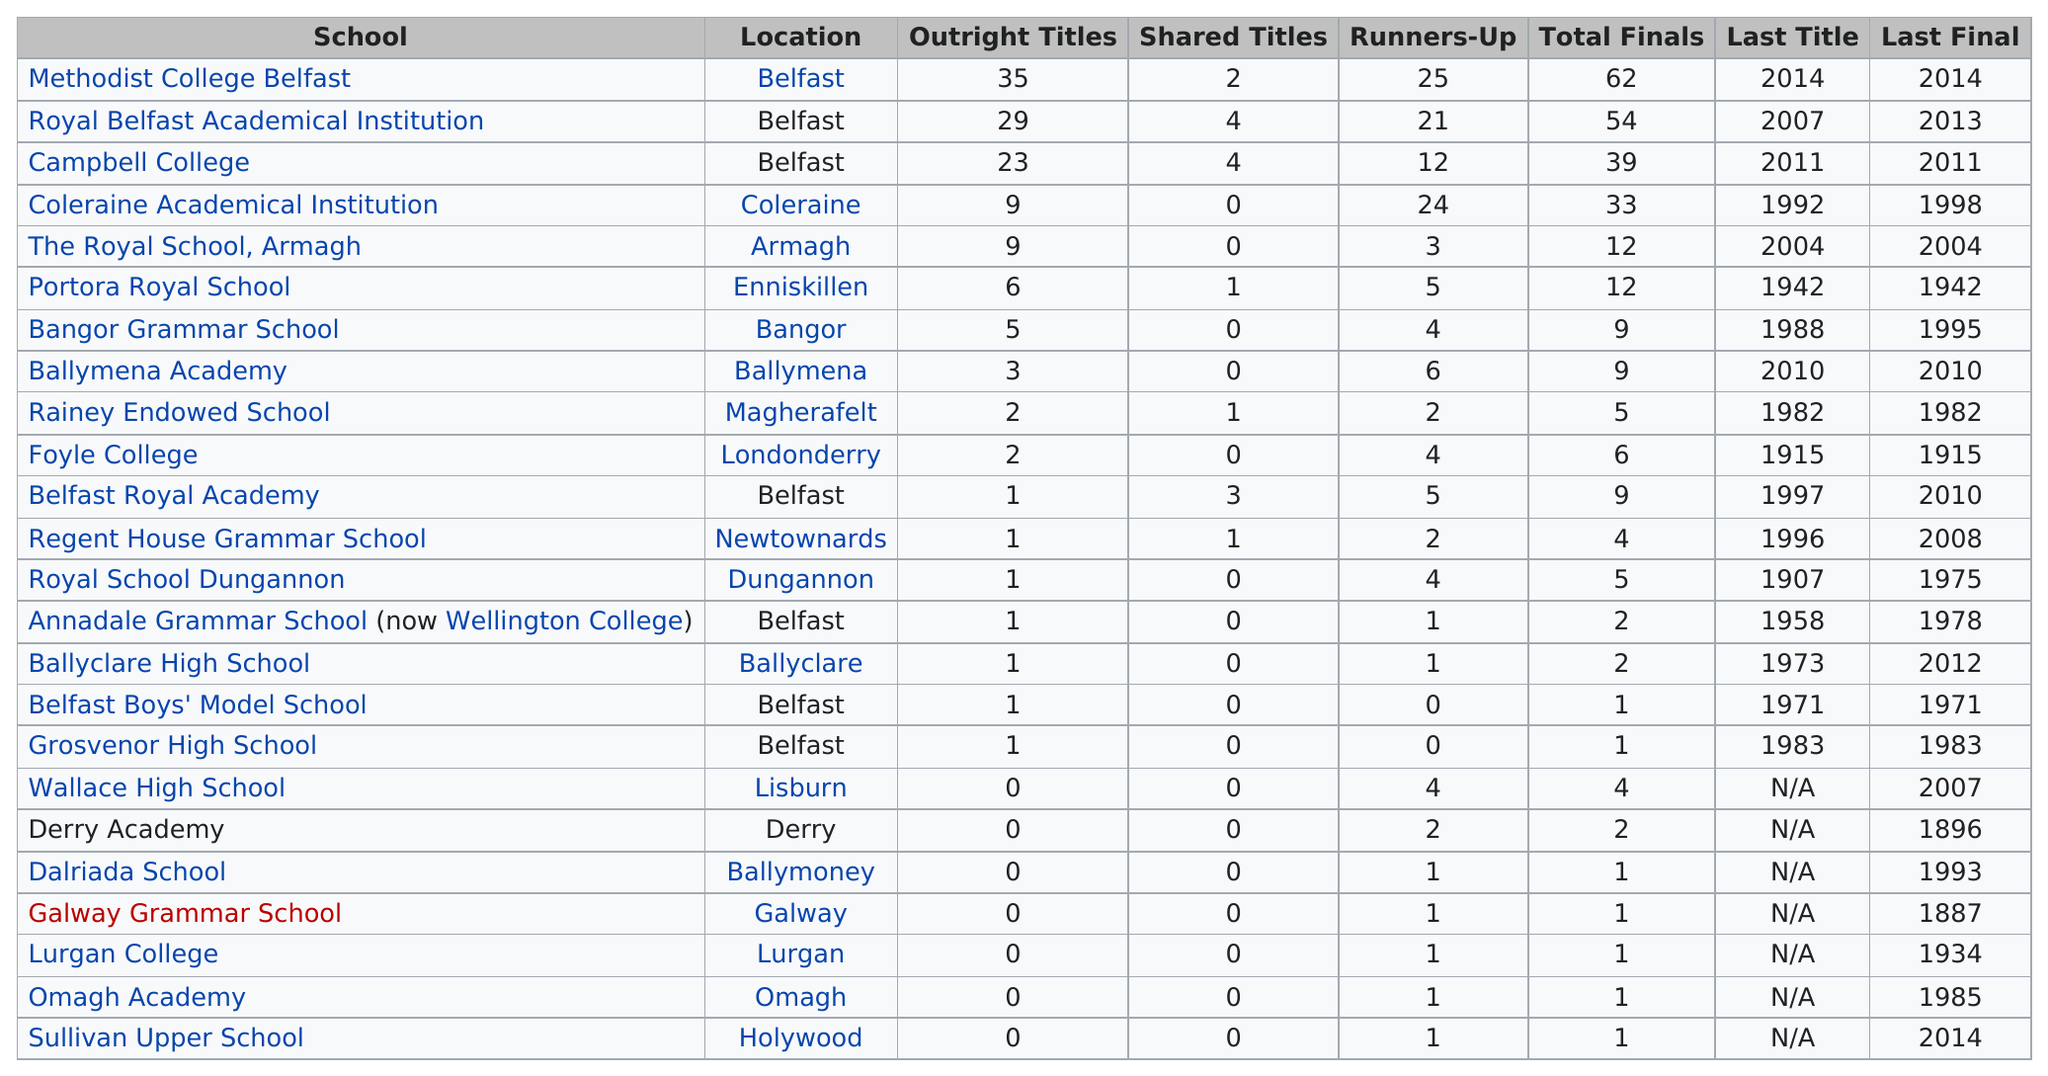Give some essential details in this illustration. The Regent House Grammar School won a title in the year 1996. There are schools, such as Methodist College Belfast and Royal Belfast Academical Institution, that have made at least 40 appearances in finals. Methodist College Belfast holds the record for having won more than 29 outright tennis championships. There were 6 schools that had more than 5 outright tennis titles. There are at least 7 schools with outright titles. 